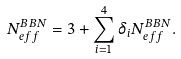<formula> <loc_0><loc_0><loc_500><loc_500>N _ { e f f } ^ { B B N } = 3 + \sum ^ { 4 } _ { i = 1 } \delta _ { i } N _ { e f f } ^ { B B N } .</formula> 